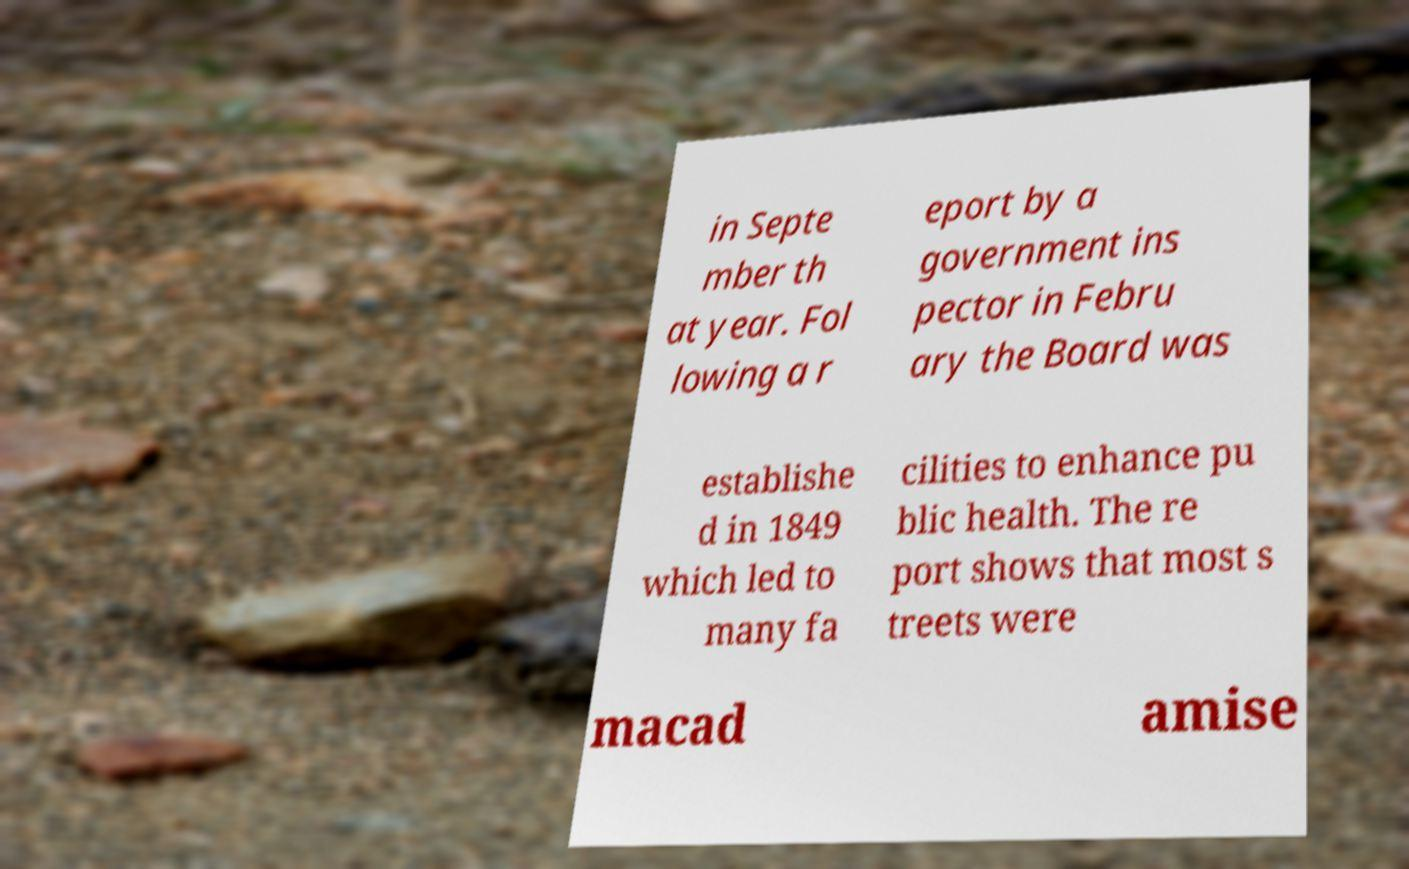Could you assist in decoding the text presented in this image and type it out clearly? in Septe mber th at year. Fol lowing a r eport by a government ins pector in Febru ary the Board was establishe d in 1849 which led to many fa cilities to enhance pu blic health. The re port shows that most s treets were macad amise 